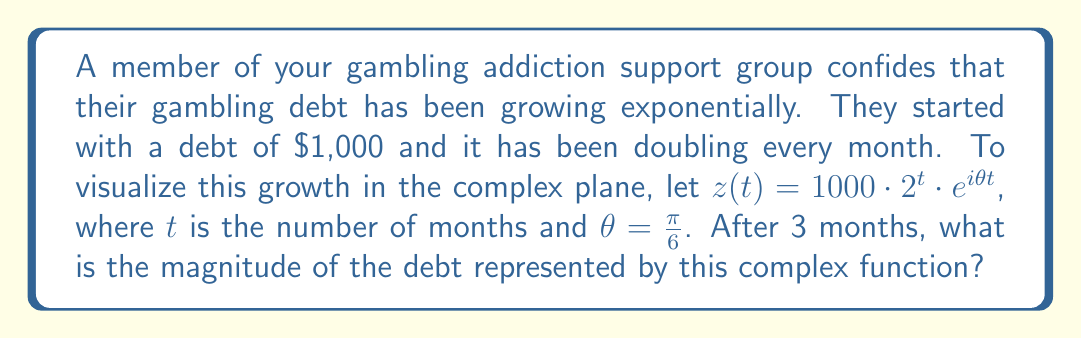Show me your answer to this math problem. Let's approach this step-by-step:

1) The given complex function is:
   $$z(t) = 1000 \cdot 2^t \cdot e^{i\theta t}$$
   where $\theta = \frac{\pi}{6}$ and $t = 3$ (months)

2) Substitute the values:
   $$z(3) = 1000 \cdot 2^3 \cdot e^{i\frac{\pi}{6}3}$$

3) Simplify the real part:
   $$1000 \cdot 2^3 = 1000 \cdot 8 = 8000$$

4) Simplify the complex exponential:
   $$e^{i\frac{\pi}{6}3} = e^{i\frac{\pi}{2}} = i$$

5) Now we have:
   $$z(3) = 8000i$$

6) To find the magnitude, we use the absolute value:
   $$|z(3)| = |8000i| = 8000$$

The magnitude of a complex number represents its distance from the origin in the complex plane, which in this case corresponds to the total debt amount.
Answer: $8000 